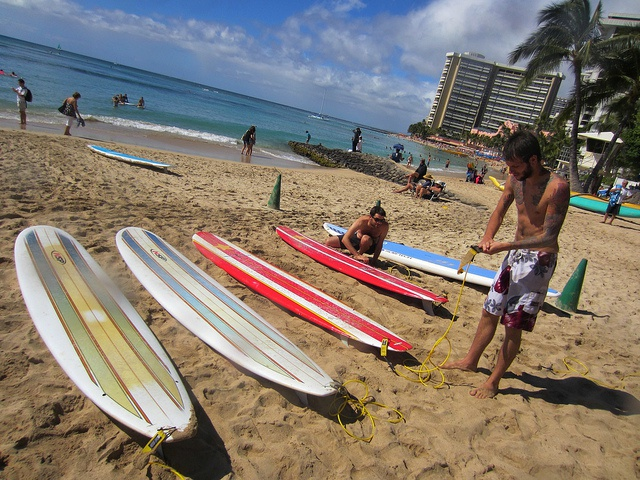Describe the objects in this image and their specific colors. I can see surfboard in darkgray, lightgray, tan, and gray tones, surfboard in darkgray, lightgray, beige, and tan tones, people in darkgray, black, maroon, brown, and gray tones, surfboard in darkgray, lightgray, salmon, and red tones, and surfboard in darkgray, brown, red, salmon, and lightgray tones in this image. 